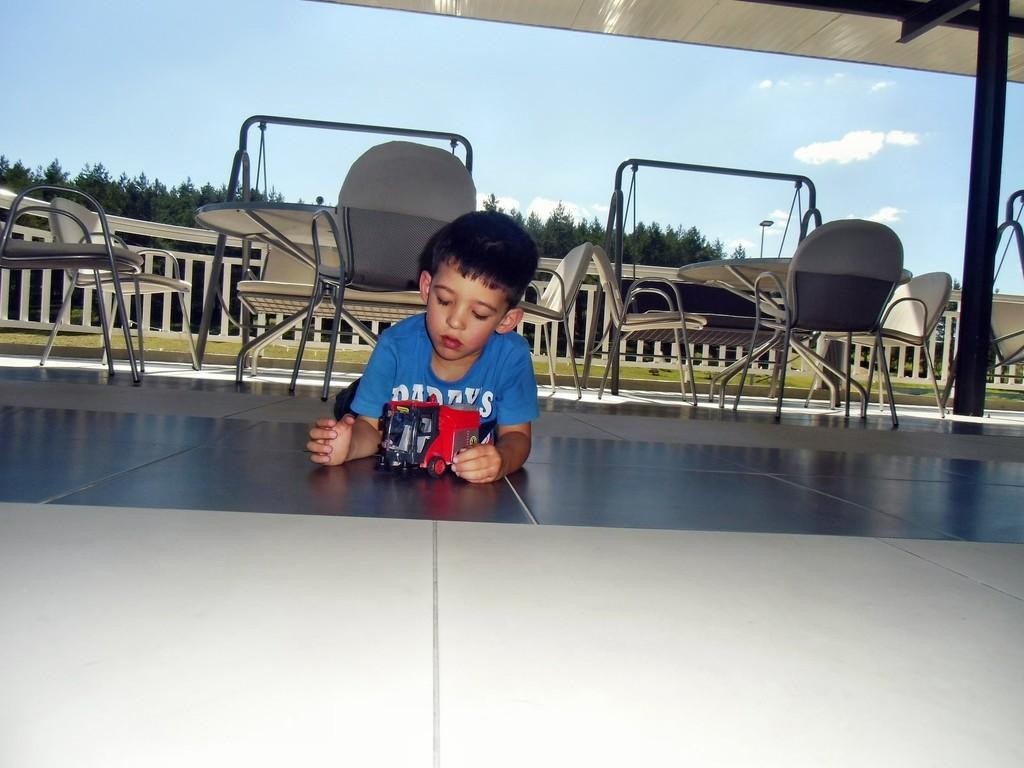Who is the main subject in the image? There is a boy in the image. What is the boy doing in the image? The boy is playing with a toy. What can be seen in the background of the image? There are tables and chairs, as well as trees, in the background of the image. What is visible at the top of the image? The sky is visible at the top of the image. How many tickets does the boy have in the image? There are no tickets present in the image. What is the distance between the boy and the sun in the image? The sun is not visible in the image, and therefore we cannot determine the distance between the boy and the sun. 